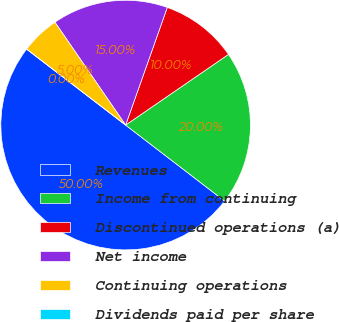<chart> <loc_0><loc_0><loc_500><loc_500><pie_chart><fcel>Revenues<fcel>Income from continuing<fcel>Discontinued operations (a)<fcel>Net income<fcel>Continuing operations<fcel>Dividends paid per share<nl><fcel>50.0%<fcel>20.0%<fcel>10.0%<fcel>15.0%<fcel>5.0%<fcel>0.0%<nl></chart> 